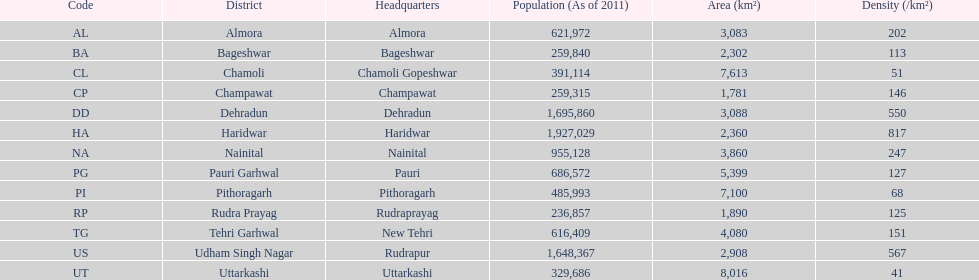Inform me of a district with a population density of just 5 Chamoli. 